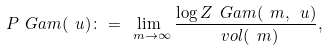<formula> <loc_0><loc_0><loc_500><loc_500>P _ { \ } G a m ( \ u ) \colon = \lim _ { \ m \to \infty } \frac { \log Z _ { \ } G a m ( \ m , \ u ) } { \ v o l ( \ m ) } ,</formula> 